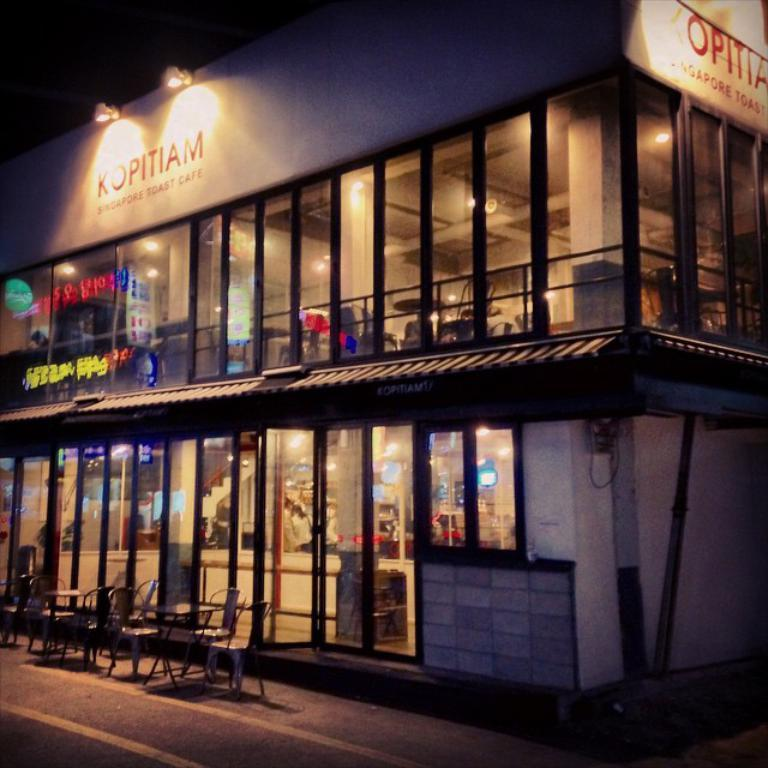What type of structure is depicted in the image? There is a building with walls and windows in the image. What can be seen near the building? There is a railing, chairs, tables, lights, and a banner present in the image. What is the purpose of the pole in the image? The pole's purpose is not explicitly mentioned, but it could be used for various purposes such as hanging signs or supporting structures. What is at the bottom of the image? A road is at the bottom of the image. How does the earthquake affect the building in the image? There is no earthquake present in the image, so its effects cannot be determined. What type of operation is being performed on the chairs in the image? There is no operation being performed on the chairs in the image; they are simply present. 